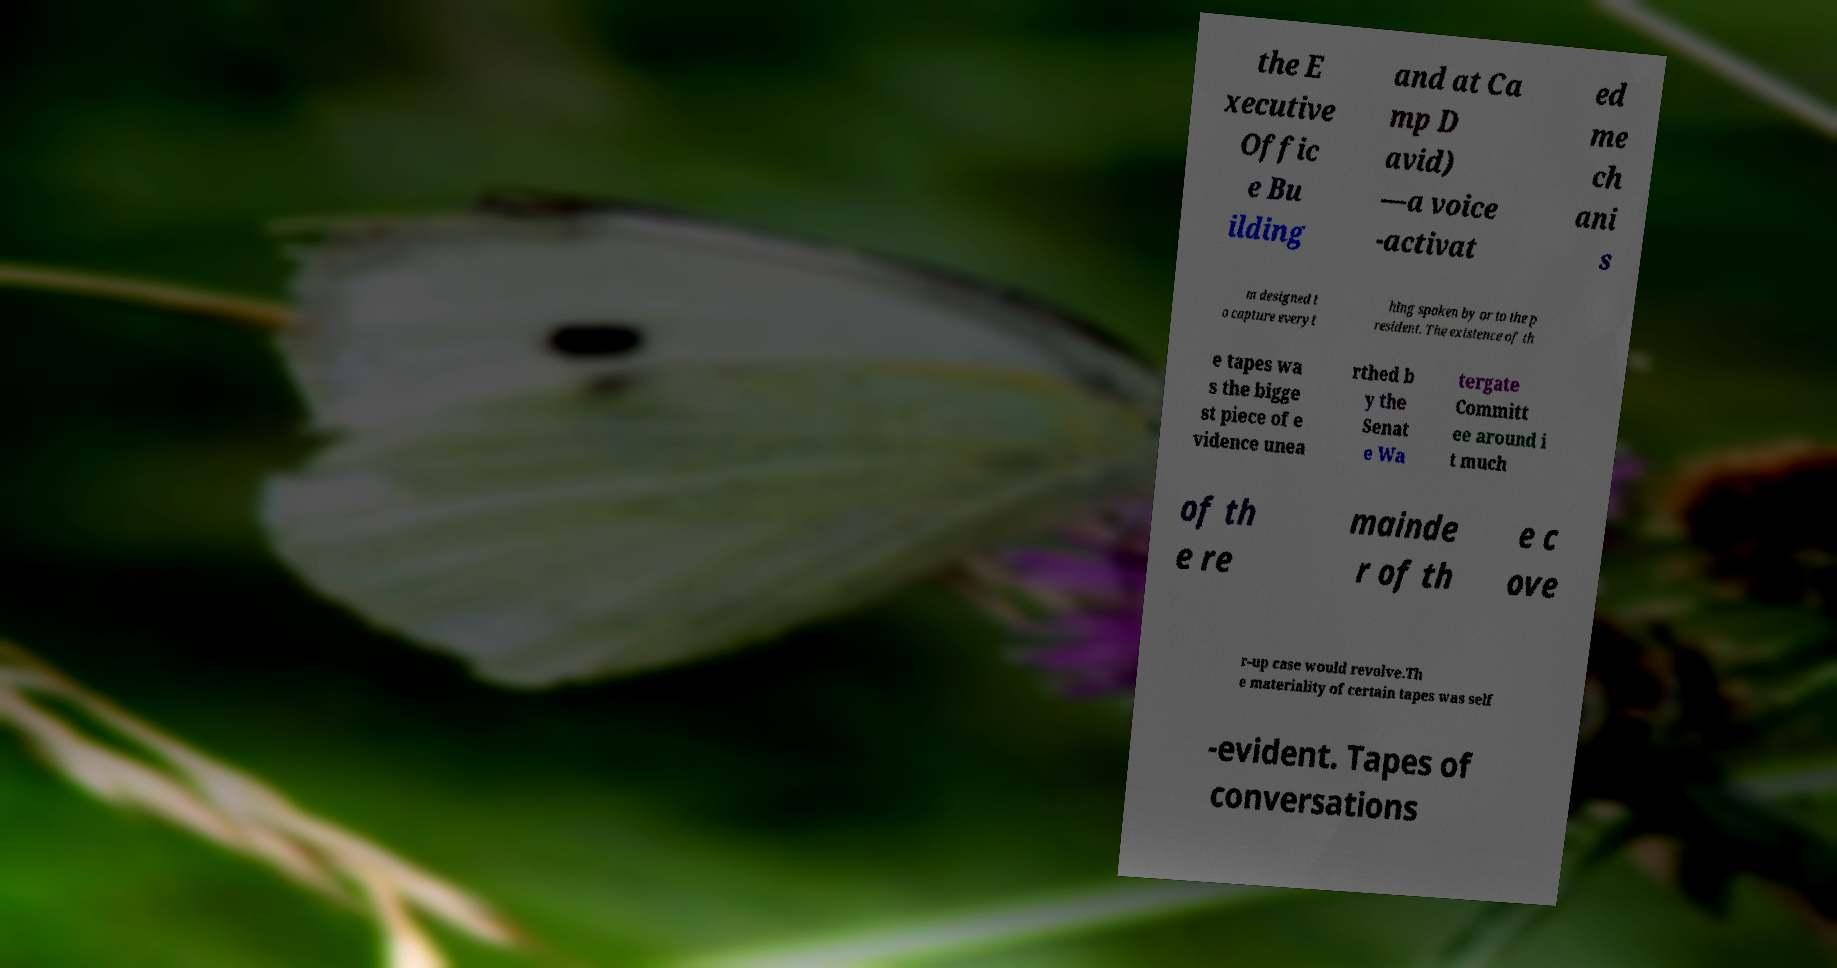I need the written content from this picture converted into text. Can you do that? the E xecutive Offic e Bu ilding and at Ca mp D avid) —a voice -activat ed me ch ani s m designed t o capture everyt hing spoken by or to the p resident. The existence of th e tapes wa s the bigge st piece of e vidence unea rthed b y the Senat e Wa tergate Committ ee around i t much of th e re mainde r of th e c ove r-up case would revolve.Th e materiality of certain tapes was self -evident. Tapes of conversations 